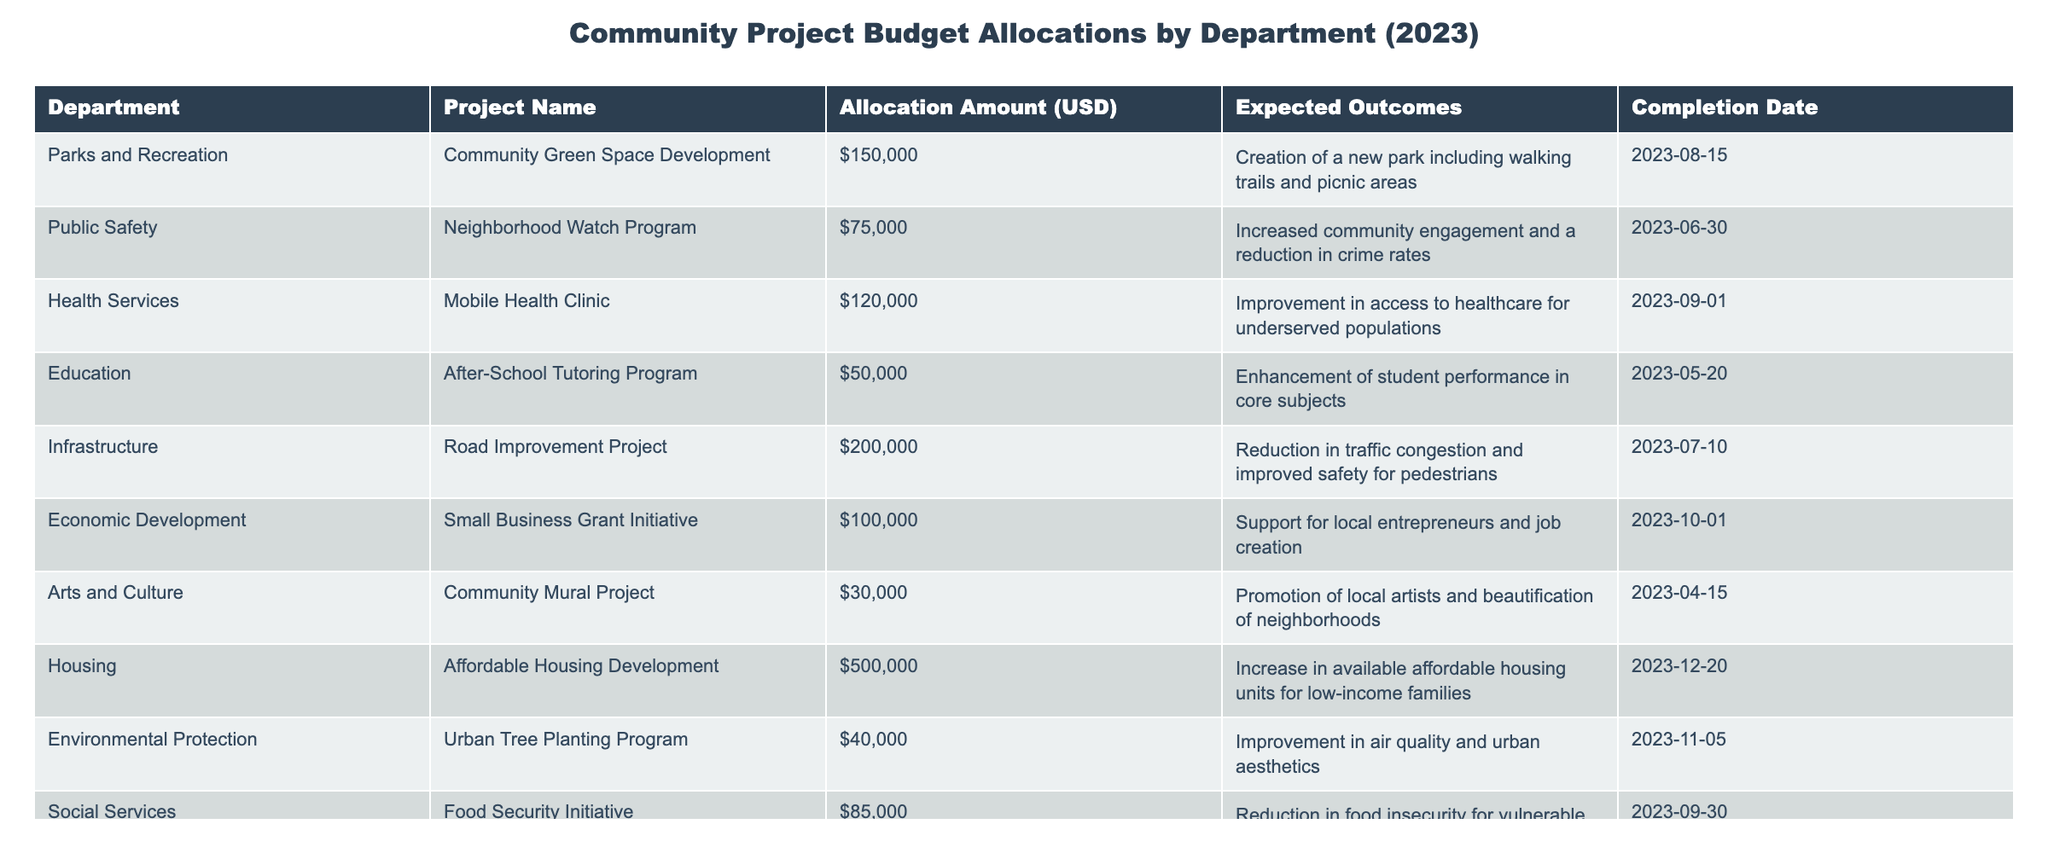What is the total budget allocation for the Health Services department? The Health Services department has one project listed, the Mobile Health Clinic, with an allocation of $120,000.
Answer: $120,000 Which project has the highest allocation amount? The project with the highest allocation amount is the Affordable Housing Development under the Housing department, with an allocation of $500,000.
Answer: Affordable Housing Development How many projects are allocated more than $100,000? There are three projects with allocations above $100,000: the Housing development ($500,000), the Infrastructure project ($200,000), and the Mobile Health Clinic ($120,000), making it a total of three projects.
Answer: 3 Does the Parks and Recreation department have any projects with expected outcomes related to education? The expected outcome for the Community Green Space Development project does not relate to education; it focuses on creating a new park. Thus, there are no education-related outcomes in this department's projects.
Answer: No What is the average allocation amount across all projects? To find the average, we sum all the allocations: $150,000 + $75,000 + $120,000 + $50,000 + $200,000 + $100,000 + $30,000 + $500,000 + $40,000 + $85,000 = $1,450,000. There are ten projects, so the average is $1,450,000 / 10 = $145,000.
Answer: $145,000 What is the expected outcome of the Neighborhood Watch Program? The expected outcome for the Neighborhood Watch Program is increased community engagement and a reduction in crime rates.
Answer: Increased community engagement and reduced crime rates How much more is allocated to the Housing department compared to the Economic Development department? The Housing department has $500,000 allocated while the Economic Development department has $100,000. The difference is $500,000 - $100,000 = $400,000.
Answer: $400,000 Are there any projects allocated less than $50,000? The projects listed do not have any allocations below $30,000, the lowest being the Community Mural Project with $30,000; therefore, the answer is no.
Answer: No Which department has the earliest completion date for their project? The project with the earliest completion date is the After-School Tutoring Program under the Education department, which is scheduled to complete on 2023-05-20.
Answer: Education department How many projects are expected to be completed after September 2023? There are two projects expected to be completed after September 2023: the Affordable Housing Development on 2023-12-20 and the Small Business Grant Initiative on 2023-10-01, totaling two projects.
Answer: 2 What is the total budget allocated to Environmental Protection and Arts and Culture departments combined? The Environmental Protection department has $40,000 allocated and the Arts and Culture department has $30,000. Together, that totals $40,000 + $30,000 = $70,000.
Answer: $70,000 